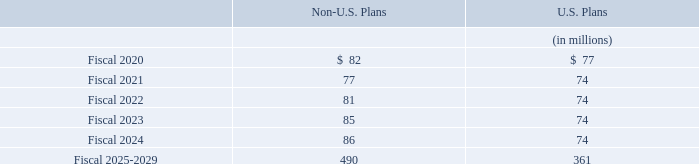Our common shares are not a direct investment of our pension funds; however, the pension funds may indirectly include our shares. The aggregate amount of our common shares would not be considered material relative to the total pension fund assets.
Our funding policy is to make contributions in accordance with the laws and customs of the various countries in which we operate as well as to make discretionary voluntary contributions from time to time. We expect to make the minimum required contributions of $42 million and $26 million to our non-U.S. and U.S. pension plans, respectively, in fiscal 2020. We may also make voluntary contributions at our discretion.
At fiscal year end 2019, benefit payments, which reflect future expected service, as appropriate, are expected to be
paid as follows:
What is the company's funding policy? To make contributions in accordance with the laws and customs of the various countries in which we operate as well as to make discretionary voluntary contributions from time to time. How much minimum required contributions is expected to be made to the non-U.S. pension plan? $42 million. Which are the periods for which benefit payments are expected to be paid? Fiscal 2020, fiscal 2021, fiscal 2022, fiscal 2023, fiscal 2024, fiscal 2025-2029. In which Fiscal year from 2020 to 2024 would the benefit payments under the U.S Plans be the largest? 77>74
Answer: fiscal 2020. What is the change in Non-U.S. benefit payments expected to be paid in Fiscal 2023 from Fiscal 2022?
Answer scale should be: million. 85-81
Answer: 4. What is the percentage change in Non-U.S. benefit payments expected to be paid in Fiscal 2023 from Fiscal 2022?
Answer scale should be: percent. (85-81)/81
Answer: 4.94. 